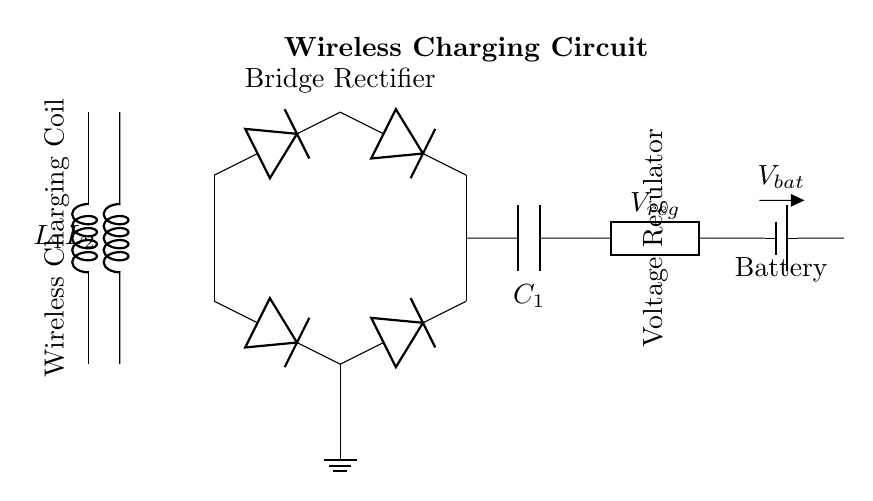What is the main function of the wireless charging coil? The wireless charging coil's main function is to create a magnetic field that enables inductive charging of the battery by transferring energy from the charging pad.
Answer: Energy transfer What type of rectifier is used in this circuit? The circuit employs a bridge rectifier, indicated by the arrangement of four diodes, which converts the alternating current (AC) produced by the wireless charging coil into direct current (DC) suitable for charging the battery.
Answer: Bridge rectifier What component is used for smoothing the output voltage? The smoothing capacitor, labeled as C1, is used to smooth the output voltage from the rectifier, reducing ripples and ensuring a more stable voltage supply to the voltage regulator.
Answer: Smoothing capacitor How many inductors are present in the circuit? There are two inductors shown in the circuit, labeled as L1 and L2, which are used for energy transfer in the wireless charging process.
Answer: Two What is the purpose of the voltage regulator in this circuit? The voltage regulator, indicated as V_reg,'s purpose is to maintain a constant voltage level to protect the battery from overcharging or voltage fluctuations during the charging process.
Answer: Maintain voltage What type of battery is used in the circuit? The battery used is specified as a battery 1, which generally refers to a rechargeable lithium-ion or lithium-polymer battery commonly used in mobile devices.
Answer: Battery 1 How does the ground connection affect this circuit? The ground connection, shown at the bottom of the circuit, serves as a common reference point for the voltages in the circuit and helps stabilize the circuit's electrical performance by minimizing noise and fluctuations.
Answer: Stabilizes performance 